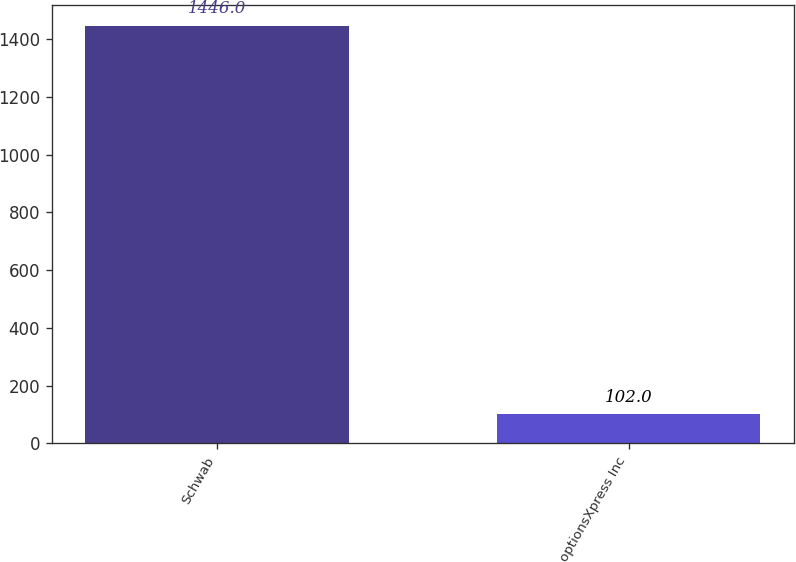<chart> <loc_0><loc_0><loc_500><loc_500><bar_chart><fcel>Schwab<fcel>optionsXpress Inc<nl><fcel>1446<fcel>102<nl></chart> 